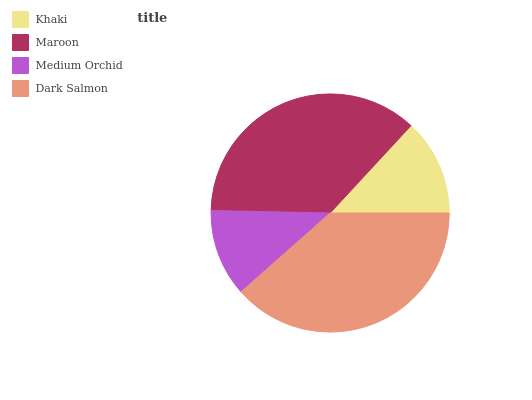Is Medium Orchid the minimum?
Answer yes or no. Yes. Is Dark Salmon the maximum?
Answer yes or no. Yes. Is Maroon the minimum?
Answer yes or no. No. Is Maroon the maximum?
Answer yes or no. No. Is Maroon greater than Khaki?
Answer yes or no. Yes. Is Khaki less than Maroon?
Answer yes or no. Yes. Is Khaki greater than Maroon?
Answer yes or no. No. Is Maroon less than Khaki?
Answer yes or no. No. Is Maroon the high median?
Answer yes or no. Yes. Is Khaki the low median?
Answer yes or no. Yes. Is Dark Salmon the high median?
Answer yes or no. No. Is Medium Orchid the low median?
Answer yes or no. No. 